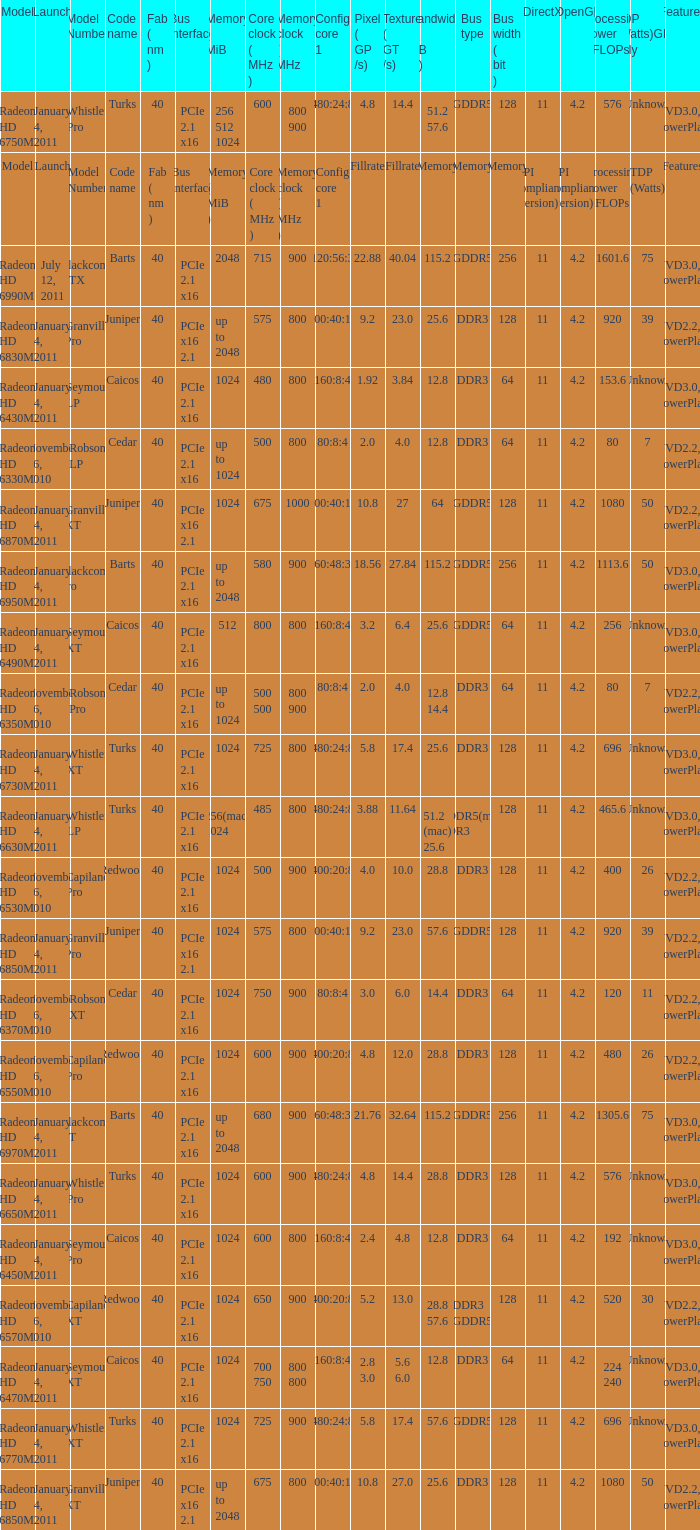What is the value for congi core 1 if the code name is Redwood and core clock(mhz) is 500? 400:20:8. 